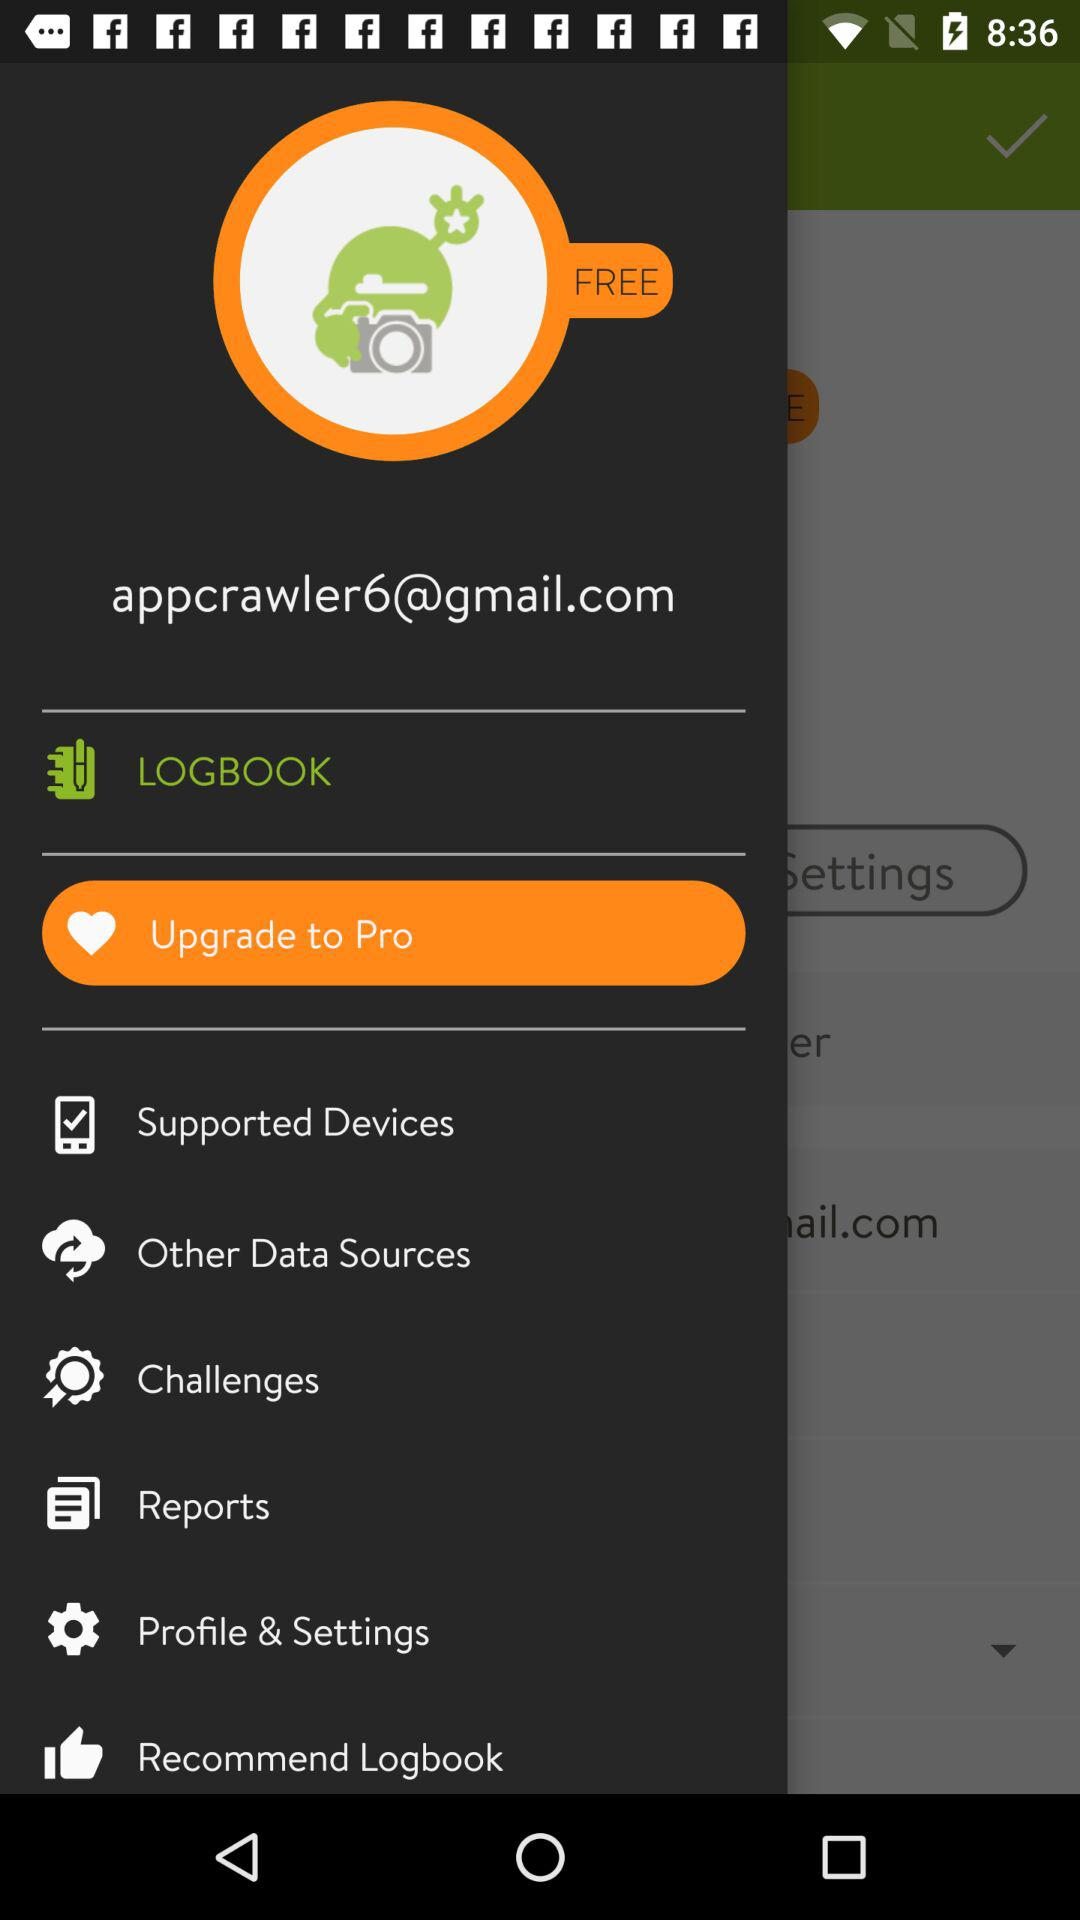Where does the user live?
When the provided information is insufficient, respond with <no answer>. <no answer> 